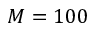Convert formula to latex. <formula><loc_0><loc_0><loc_500><loc_500>M = 1 0 0</formula> 